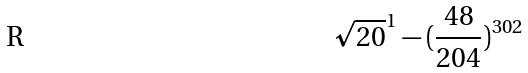<formula> <loc_0><loc_0><loc_500><loc_500>\sqrt { 2 0 } ^ { 1 } - ( \frac { 4 8 } { 2 0 4 } ) ^ { 3 0 2 }</formula> 